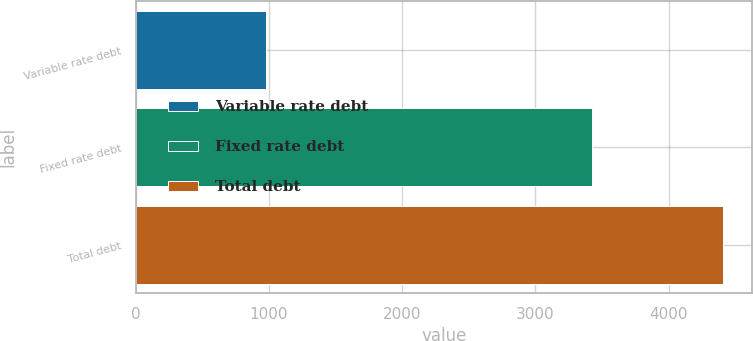Convert chart. <chart><loc_0><loc_0><loc_500><loc_500><bar_chart><fcel>Variable rate debt<fcel>Fixed rate debt<fcel>Total debt<nl><fcel>976.3<fcel>3427.1<fcel>4403.4<nl></chart> 